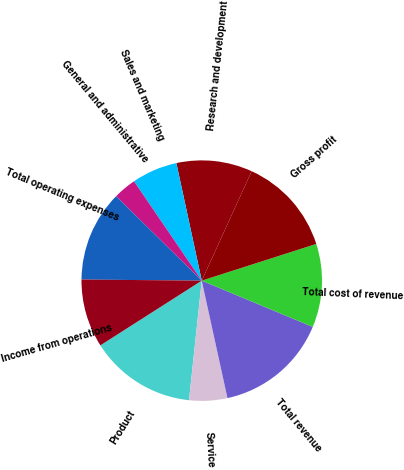Convert chart. <chart><loc_0><loc_0><loc_500><loc_500><pie_chart><fcel>Product<fcel>Service<fcel>Total revenue<fcel>Total cost of revenue<fcel>Gross profit<fcel>Research and development<fcel>Sales and marketing<fcel>General and administrative<fcel>Total operating expenses<fcel>Income from operations<nl><fcel>14.27%<fcel>5.12%<fcel>15.29%<fcel>11.22%<fcel>13.25%<fcel>10.2%<fcel>6.14%<fcel>3.09%<fcel>12.24%<fcel>9.19%<nl></chart> 